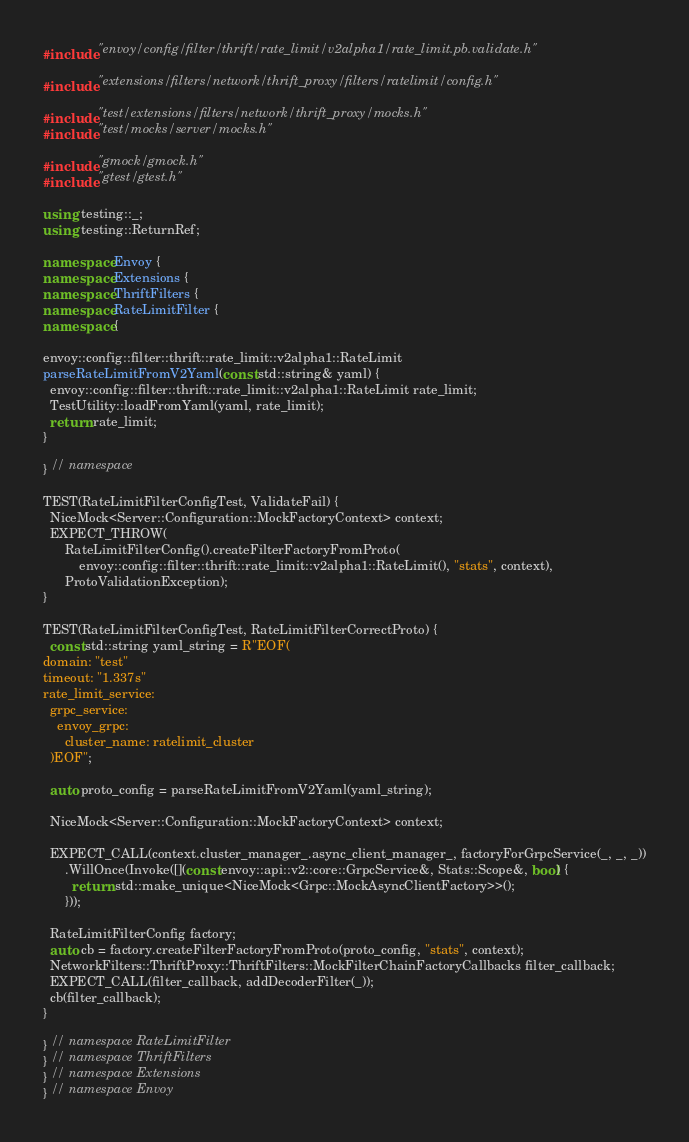<code> <loc_0><loc_0><loc_500><loc_500><_C++_>#include "envoy/config/filter/thrift/rate_limit/v2alpha1/rate_limit.pb.validate.h"

#include "extensions/filters/network/thrift_proxy/filters/ratelimit/config.h"

#include "test/extensions/filters/network/thrift_proxy/mocks.h"
#include "test/mocks/server/mocks.h"

#include "gmock/gmock.h"
#include "gtest/gtest.h"

using testing::_;
using testing::ReturnRef;

namespace Envoy {
namespace Extensions {
namespace ThriftFilters {
namespace RateLimitFilter {
namespace {

envoy::config::filter::thrift::rate_limit::v2alpha1::RateLimit
parseRateLimitFromV2Yaml(const std::string& yaml) {
  envoy::config::filter::thrift::rate_limit::v2alpha1::RateLimit rate_limit;
  TestUtility::loadFromYaml(yaml, rate_limit);
  return rate_limit;
}

} // namespace

TEST(RateLimitFilterConfigTest, ValidateFail) {
  NiceMock<Server::Configuration::MockFactoryContext> context;
  EXPECT_THROW(
      RateLimitFilterConfig().createFilterFactoryFromProto(
          envoy::config::filter::thrift::rate_limit::v2alpha1::RateLimit(), "stats", context),
      ProtoValidationException);
}

TEST(RateLimitFilterConfigTest, RateLimitFilterCorrectProto) {
  const std::string yaml_string = R"EOF(
domain: "test"
timeout: "1.337s"
rate_limit_service:
  grpc_service:
    envoy_grpc:
      cluster_name: ratelimit_cluster
  )EOF";

  auto proto_config = parseRateLimitFromV2Yaml(yaml_string);

  NiceMock<Server::Configuration::MockFactoryContext> context;

  EXPECT_CALL(context.cluster_manager_.async_client_manager_, factoryForGrpcService(_, _, _))
      .WillOnce(Invoke([](const envoy::api::v2::core::GrpcService&, Stats::Scope&, bool) {
        return std::make_unique<NiceMock<Grpc::MockAsyncClientFactory>>();
      }));

  RateLimitFilterConfig factory;
  auto cb = factory.createFilterFactoryFromProto(proto_config, "stats", context);
  NetworkFilters::ThriftProxy::ThriftFilters::MockFilterChainFactoryCallbacks filter_callback;
  EXPECT_CALL(filter_callback, addDecoderFilter(_));
  cb(filter_callback);
}

} // namespace RateLimitFilter
} // namespace ThriftFilters
} // namespace Extensions
} // namespace Envoy
</code> 